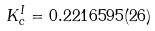Convert formula to latex. <formula><loc_0><loc_0><loc_500><loc_500>K _ { c } ^ { I } = 0 . 2 2 1 6 5 9 5 ( 2 6 )</formula> 